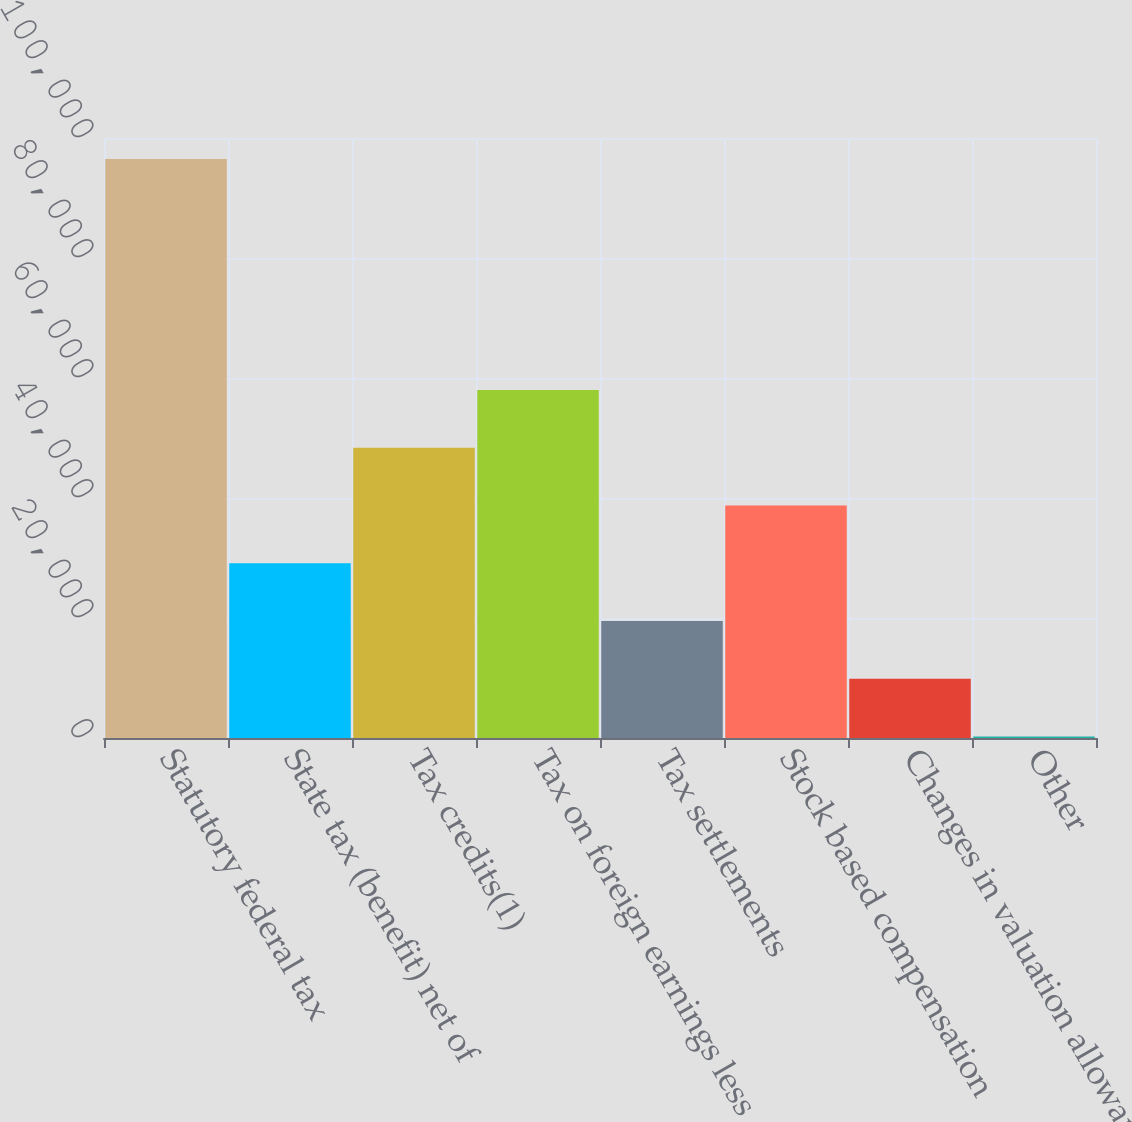Convert chart to OTSL. <chart><loc_0><loc_0><loc_500><loc_500><bar_chart><fcel>Statutory federal tax<fcel>State tax (benefit) net of<fcel>Tax credits(1)<fcel>Tax on foreign earnings less<fcel>Tax settlements<fcel>Stock based compensation<fcel>Changes in valuation allowance<fcel>Other<nl><fcel>96483<fcel>29109.4<fcel>48359<fcel>57983.8<fcel>19484.6<fcel>38734.2<fcel>9859.8<fcel>235<nl></chart> 